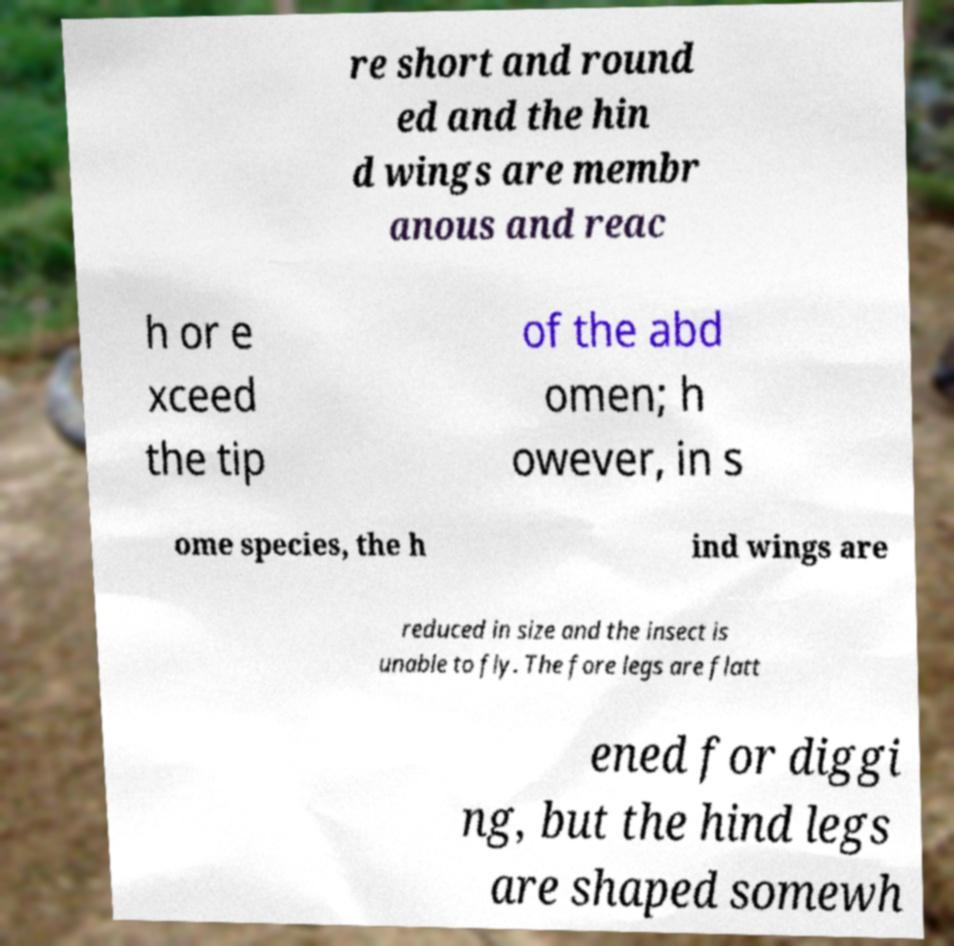Please read and relay the text visible in this image. What does it say? re short and round ed and the hin d wings are membr anous and reac h or e xceed the tip of the abd omen; h owever, in s ome species, the h ind wings are reduced in size and the insect is unable to fly. The fore legs are flatt ened for diggi ng, but the hind legs are shaped somewh 